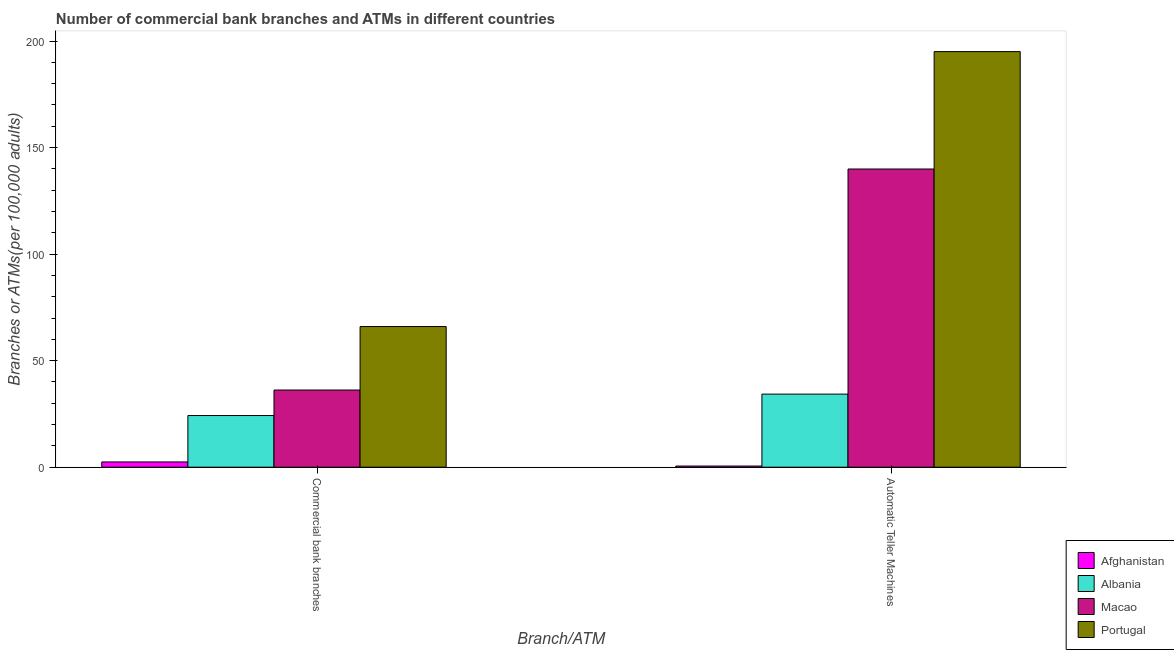How many different coloured bars are there?
Offer a terse response. 4. How many groups of bars are there?
Your response must be concise. 2. Are the number of bars on each tick of the X-axis equal?
Give a very brief answer. Yes. What is the label of the 1st group of bars from the left?
Your answer should be very brief. Commercial bank branches. What is the number of commercal bank branches in Afghanistan?
Offer a terse response. 2.47. Across all countries, what is the maximum number of commercal bank branches?
Your answer should be very brief. 66.01. Across all countries, what is the minimum number of atms?
Give a very brief answer. 0.55. In which country was the number of commercal bank branches maximum?
Make the answer very short. Portugal. In which country was the number of commercal bank branches minimum?
Ensure brevity in your answer.  Afghanistan. What is the total number of commercal bank branches in the graph?
Ensure brevity in your answer.  128.95. What is the difference between the number of commercal bank branches in Afghanistan and that in Macao?
Offer a terse response. -33.75. What is the difference between the number of commercal bank branches in Macao and the number of atms in Albania?
Your answer should be very brief. 1.92. What is the average number of atms per country?
Provide a succinct answer. 92.46. What is the difference between the number of commercal bank branches and number of atms in Portugal?
Offer a very short reply. -129.03. What is the ratio of the number of commercal bank branches in Portugal to that in Albania?
Offer a terse response. 2.72. Is the number of atms in Portugal less than that in Afghanistan?
Ensure brevity in your answer.  No. What does the 4th bar from the left in Automatic Teller Machines represents?
Your response must be concise. Portugal. What does the 1st bar from the right in Automatic Teller Machines represents?
Provide a short and direct response. Portugal. How many bars are there?
Your answer should be compact. 8. How many countries are there in the graph?
Offer a very short reply. 4. What is the difference between two consecutive major ticks on the Y-axis?
Provide a short and direct response. 50. Are the values on the major ticks of Y-axis written in scientific E-notation?
Your answer should be very brief. No. Does the graph contain any zero values?
Make the answer very short. No. Does the graph contain grids?
Your answer should be compact. No. How many legend labels are there?
Provide a short and direct response. 4. How are the legend labels stacked?
Your answer should be compact. Vertical. What is the title of the graph?
Provide a short and direct response. Number of commercial bank branches and ATMs in different countries. What is the label or title of the X-axis?
Give a very brief answer. Branch/ATM. What is the label or title of the Y-axis?
Make the answer very short. Branches or ATMs(per 100,0 adults). What is the Branches or ATMs(per 100,000 adults) of Afghanistan in Commercial bank branches?
Make the answer very short. 2.47. What is the Branches or ATMs(per 100,000 adults) in Albania in Commercial bank branches?
Provide a short and direct response. 24.24. What is the Branches or ATMs(per 100,000 adults) of Macao in Commercial bank branches?
Keep it short and to the point. 36.22. What is the Branches or ATMs(per 100,000 adults) in Portugal in Commercial bank branches?
Your response must be concise. 66.01. What is the Branches or ATMs(per 100,000 adults) in Afghanistan in Automatic Teller Machines?
Offer a terse response. 0.55. What is the Branches or ATMs(per 100,000 adults) in Albania in Automatic Teller Machines?
Your response must be concise. 34.3. What is the Branches or ATMs(per 100,000 adults) in Macao in Automatic Teller Machines?
Your answer should be very brief. 139.95. What is the Branches or ATMs(per 100,000 adults) in Portugal in Automatic Teller Machines?
Keep it short and to the point. 195.04. Across all Branch/ATM, what is the maximum Branches or ATMs(per 100,000 adults) of Afghanistan?
Provide a succinct answer. 2.47. Across all Branch/ATM, what is the maximum Branches or ATMs(per 100,000 adults) of Albania?
Make the answer very short. 34.3. Across all Branch/ATM, what is the maximum Branches or ATMs(per 100,000 adults) of Macao?
Your answer should be compact. 139.95. Across all Branch/ATM, what is the maximum Branches or ATMs(per 100,000 adults) of Portugal?
Make the answer very short. 195.04. Across all Branch/ATM, what is the minimum Branches or ATMs(per 100,000 adults) in Afghanistan?
Ensure brevity in your answer.  0.55. Across all Branch/ATM, what is the minimum Branches or ATMs(per 100,000 adults) of Albania?
Your answer should be compact. 24.24. Across all Branch/ATM, what is the minimum Branches or ATMs(per 100,000 adults) in Macao?
Your answer should be compact. 36.22. Across all Branch/ATM, what is the minimum Branches or ATMs(per 100,000 adults) in Portugal?
Make the answer very short. 66.01. What is the total Branches or ATMs(per 100,000 adults) in Afghanistan in the graph?
Your answer should be compact. 3.02. What is the total Branches or ATMs(per 100,000 adults) in Albania in the graph?
Offer a terse response. 58.54. What is the total Branches or ATMs(per 100,000 adults) in Macao in the graph?
Provide a succinct answer. 176.16. What is the total Branches or ATMs(per 100,000 adults) of Portugal in the graph?
Provide a short and direct response. 261.05. What is the difference between the Branches or ATMs(per 100,000 adults) in Afghanistan in Commercial bank branches and that in Automatic Teller Machines?
Provide a short and direct response. 1.93. What is the difference between the Branches or ATMs(per 100,000 adults) of Albania in Commercial bank branches and that in Automatic Teller Machines?
Your answer should be compact. -10.05. What is the difference between the Branches or ATMs(per 100,000 adults) of Macao in Commercial bank branches and that in Automatic Teller Machines?
Your answer should be compact. -103.73. What is the difference between the Branches or ATMs(per 100,000 adults) of Portugal in Commercial bank branches and that in Automatic Teller Machines?
Give a very brief answer. -129.03. What is the difference between the Branches or ATMs(per 100,000 adults) of Afghanistan in Commercial bank branches and the Branches or ATMs(per 100,000 adults) of Albania in Automatic Teller Machines?
Ensure brevity in your answer.  -31.82. What is the difference between the Branches or ATMs(per 100,000 adults) in Afghanistan in Commercial bank branches and the Branches or ATMs(per 100,000 adults) in Macao in Automatic Teller Machines?
Your response must be concise. -137.47. What is the difference between the Branches or ATMs(per 100,000 adults) of Afghanistan in Commercial bank branches and the Branches or ATMs(per 100,000 adults) of Portugal in Automatic Teller Machines?
Offer a very short reply. -192.57. What is the difference between the Branches or ATMs(per 100,000 adults) of Albania in Commercial bank branches and the Branches or ATMs(per 100,000 adults) of Macao in Automatic Teller Machines?
Make the answer very short. -115.7. What is the difference between the Branches or ATMs(per 100,000 adults) in Albania in Commercial bank branches and the Branches or ATMs(per 100,000 adults) in Portugal in Automatic Teller Machines?
Your answer should be very brief. -170.8. What is the difference between the Branches or ATMs(per 100,000 adults) in Macao in Commercial bank branches and the Branches or ATMs(per 100,000 adults) in Portugal in Automatic Teller Machines?
Offer a very short reply. -158.82. What is the average Branches or ATMs(per 100,000 adults) of Afghanistan per Branch/ATM?
Your answer should be compact. 1.51. What is the average Branches or ATMs(per 100,000 adults) in Albania per Branch/ATM?
Keep it short and to the point. 29.27. What is the average Branches or ATMs(per 100,000 adults) in Macao per Branch/ATM?
Your answer should be very brief. 88.08. What is the average Branches or ATMs(per 100,000 adults) of Portugal per Branch/ATM?
Provide a succinct answer. 130.53. What is the difference between the Branches or ATMs(per 100,000 adults) of Afghanistan and Branches or ATMs(per 100,000 adults) of Albania in Commercial bank branches?
Offer a terse response. -21.77. What is the difference between the Branches or ATMs(per 100,000 adults) in Afghanistan and Branches or ATMs(per 100,000 adults) in Macao in Commercial bank branches?
Your answer should be very brief. -33.75. What is the difference between the Branches or ATMs(per 100,000 adults) in Afghanistan and Branches or ATMs(per 100,000 adults) in Portugal in Commercial bank branches?
Offer a very short reply. -63.54. What is the difference between the Branches or ATMs(per 100,000 adults) of Albania and Branches or ATMs(per 100,000 adults) of Macao in Commercial bank branches?
Your response must be concise. -11.98. What is the difference between the Branches or ATMs(per 100,000 adults) in Albania and Branches or ATMs(per 100,000 adults) in Portugal in Commercial bank branches?
Keep it short and to the point. -41.77. What is the difference between the Branches or ATMs(per 100,000 adults) in Macao and Branches or ATMs(per 100,000 adults) in Portugal in Commercial bank branches?
Offer a very short reply. -29.79. What is the difference between the Branches or ATMs(per 100,000 adults) of Afghanistan and Branches or ATMs(per 100,000 adults) of Albania in Automatic Teller Machines?
Offer a terse response. -33.75. What is the difference between the Branches or ATMs(per 100,000 adults) of Afghanistan and Branches or ATMs(per 100,000 adults) of Macao in Automatic Teller Machines?
Offer a very short reply. -139.4. What is the difference between the Branches or ATMs(per 100,000 adults) in Afghanistan and Branches or ATMs(per 100,000 adults) in Portugal in Automatic Teller Machines?
Give a very brief answer. -194.5. What is the difference between the Branches or ATMs(per 100,000 adults) of Albania and Branches or ATMs(per 100,000 adults) of Macao in Automatic Teller Machines?
Offer a very short reply. -105.65. What is the difference between the Branches or ATMs(per 100,000 adults) of Albania and Branches or ATMs(per 100,000 adults) of Portugal in Automatic Teller Machines?
Give a very brief answer. -160.75. What is the difference between the Branches or ATMs(per 100,000 adults) in Macao and Branches or ATMs(per 100,000 adults) in Portugal in Automatic Teller Machines?
Offer a very short reply. -55.1. What is the ratio of the Branches or ATMs(per 100,000 adults) in Afghanistan in Commercial bank branches to that in Automatic Teller Machines?
Provide a short and direct response. 4.51. What is the ratio of the Branches or ATMs(per 100,000 adults) of Albania in Commercial bank branches to that in Automatic Teller Machines?
Provide a short and direct response. 0.71. What is the ratio of the Branches or ATMs(per 100,000 adults) in Macao in Commercial bank branches to that in Automatic Teller Machines?
Give a very brief answer. 0.26. What is the ratio of the Branches or ATMs(per 100,000 adults) of Portugal in Commercial bank branches to that in Automatic Teller Machines?
Give a very brief answer. 0.34. What is the difference between the highest and the second highest Branches or ATMs(per 100,000 adults) of Afghanistan?
Your answer should be compact. 1.93. What is the difference between the highest and the second highest Branches or ATMs(per 100,000 adults) of Albania?
Offer a very short reply. 10.05. What is the difference between the highest and the second highest Branches or ATMs(per 100,000 adults) in Macao?
Give a very brief answer. 103.73. What is the difference between the highest and the second highest Branches or ATMs(per 100,000 adults) in Portugal?
Provide a succinct answer. 129.03. What is the difference between the highest and the lowest Branches or ATMs(per 100,000 adults) of Afghanistan?
Provide a short and direct response. 1.93. What is the difference between the highest and the lowest Branches or ATMs(per 100,000 adults) of Albania?
Make the answer very short. 10.05. What is the difference between the highest and the lowest Branches or ATMs(per 100,000 adults) in Macao?
Keep it short and to the point. 103.73. What is the difference between the highest and the lowest Branches or ATMs(per 100,000 adults) in Portugal?
Your response must be concise. 129.03. 